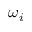Convert formula to latex. <formula><loc_0><loc_0><loc_500><loc_500>\omega _ { i }</formula> 